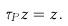Convert formula to latex. <formula><loc_0><loc_0><loc_500><loc_500>\tau _ { P } z = z .</formula> 